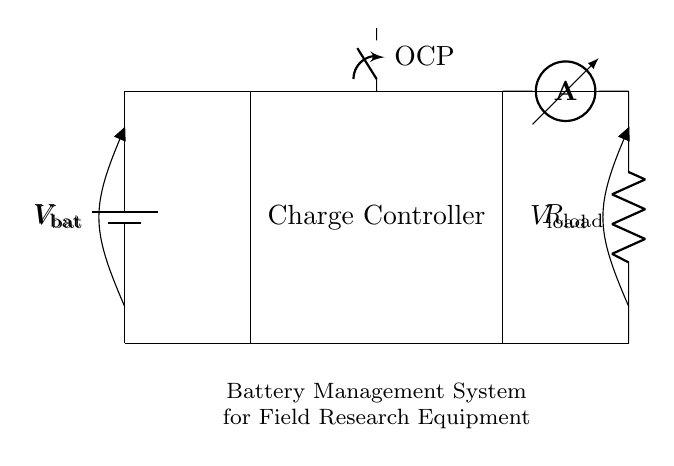What type of protection is implemented in the circuit? The circuit includes an Overcharge Protection (OCP) mechanism, indicated by the closing switch symbol. This component serves to prevent excessive charging of the battery, thus safeguarding it from potential damage.
Answer: Overcharge Protection What components are present in the circuit? The components in the circuit include a battery, a charge controller, an overcharge protection switch, a load resistor, and an ammeter. Each of these elements plays a role in managing the battery's performance and ensuring safe operation.
Answer: Battery, Charge Controller, OCP, Load, Ammeter What is the purpose of the charge controller? The charge controller regulates the voltage and current going to the battery during charging, ensuring that it does not receive an excessive charge which could lead to damage. Its primary purpose is to extend the life of the battery by preventing overcharging.
Answer: Regulates voltage and current Where is the load connected in the circuit? The load is connected at the output of the charge controller, indicated by the connection point on the right side of the diagram labeled with the load resistor. This allows the load to draw energy from the battery through the charge controller.
Answer: Right side How does the circuit prevent battery overcharging? The circuit includes a closing switch labeled OCP which is part of the overcharge protection mechanism. When the battery voltage exceeds safe levels, this switch opens, stopping the charging current and thereby preventing overcharging. This action is crucial for protecting the battery's longevity.
Answer: Opens switch What is the purpose of the ammeter in the circuit? The ammeter is used to measure the current flowing through the load. By connecting it in series with the load, it provides valuable information on how much current is being drawn, which helps ensure the system operates within expected parameters and aids in troubleshooting if issues arise.
Answer: Measures current What does the voltage measurement indicate in the circuit? The voltage measurement points at the battery and load indicate the potential difference across these components. This information is critical for understanding the performance of both the battery and the load in the circuit, allowing for proper assessment of energy usage and battery status.
Answer: Potential difference 